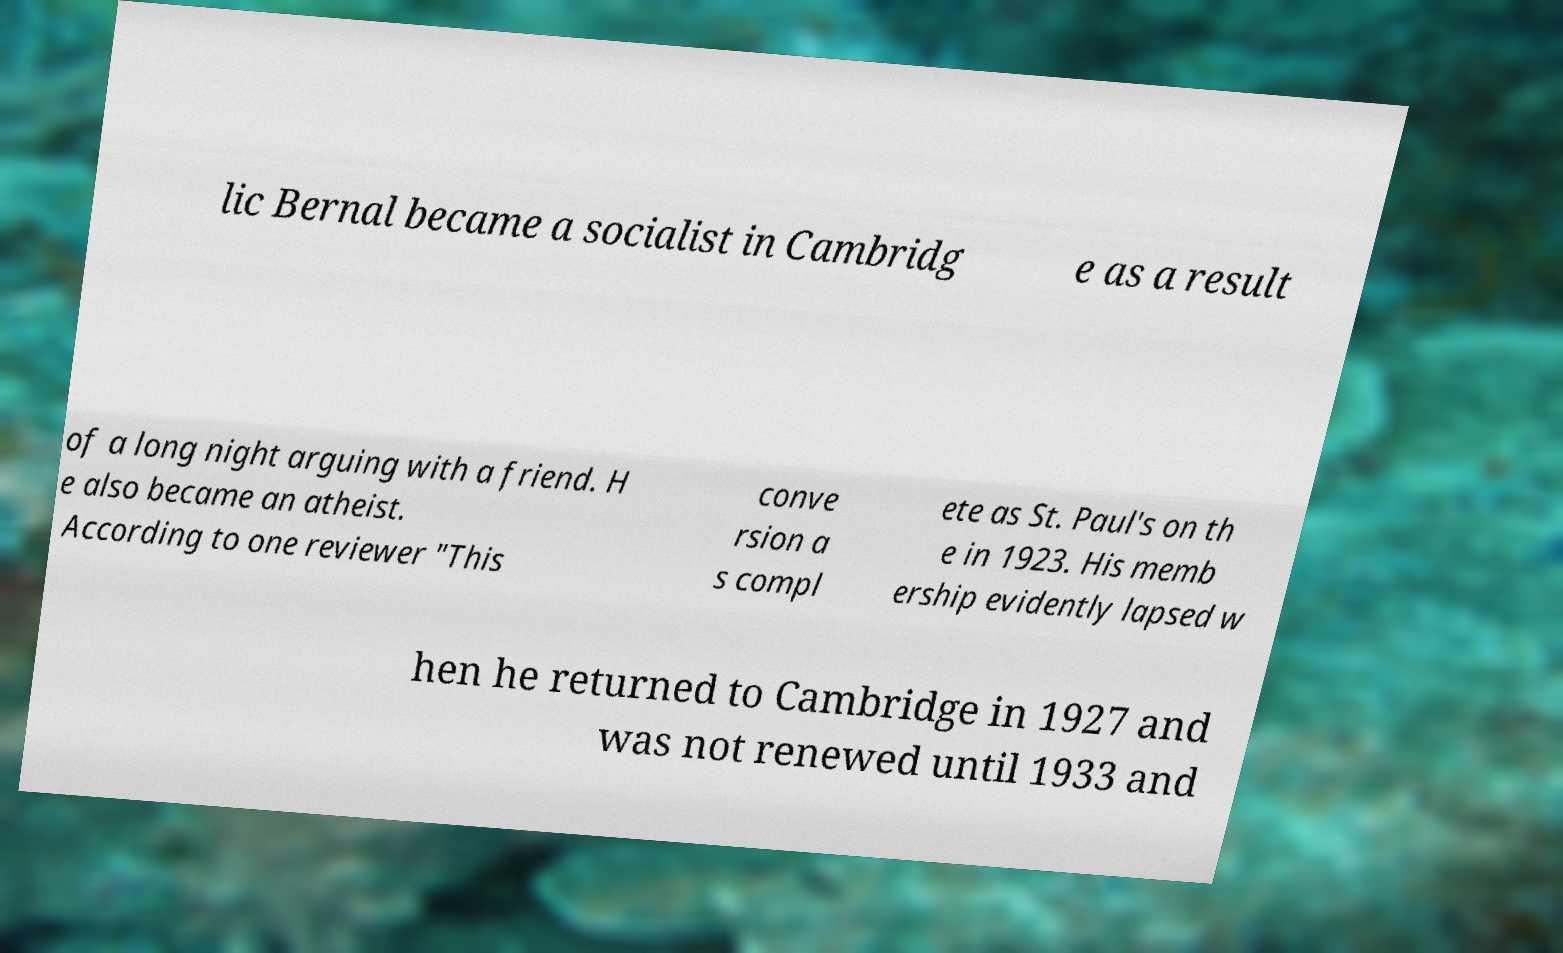What messages or text are displayed in this image? I need them in a readable, typed format. lic Bernal became a socialist in Cambridg e as a result of a long night arguing with a friend. H e also became an atheist. According to one reviewer "This conve rsion a s compl ete as St. Paul's on th e in 1923. His memb ership evidently lapsed w hen he returned to Cambridge in 1927 and was not renewed until 1933 and 